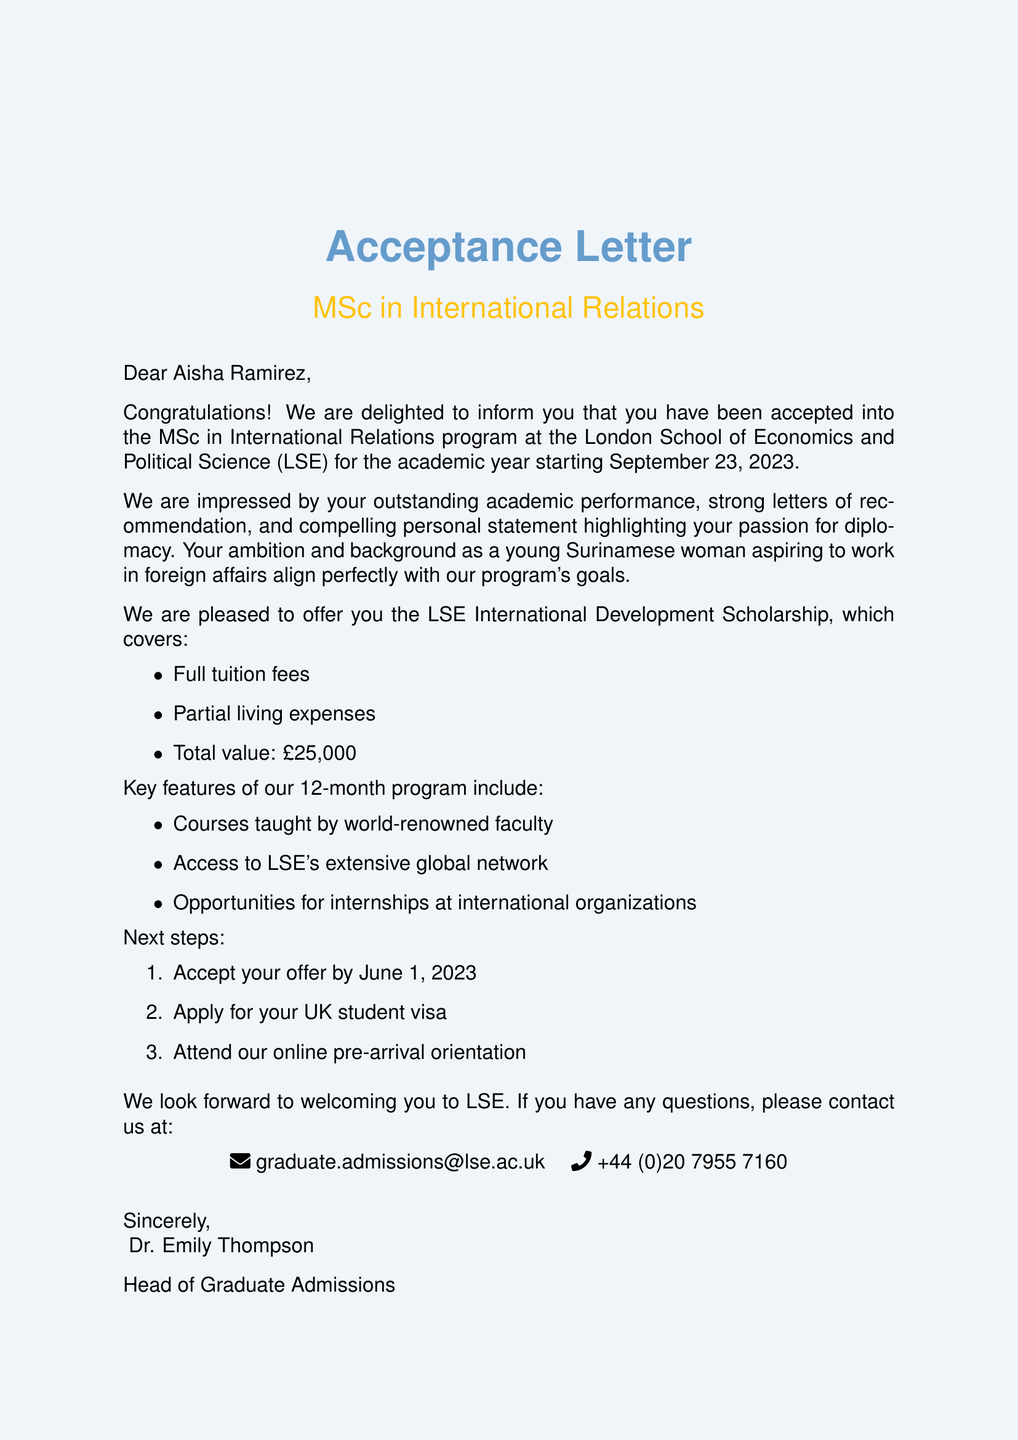What is the name of the university? The university mentioned in the document is the London School of Economics and Political Science.
Answer: London School of Economics and Political Science What is the scholarship amount? The scholarship amount offered is clearly stated in the document.
Answer: £25,000 What is the program duration? The duration of the MSc in International Relations program is specified in the document.
Answer: 12 months Who is the head of graduate admissions? The document provides the name and title of the admissions officer.
Answer: Dr. Emily Thompson By what date should the offer be accepted? The document outlines the deadline for accepting the offer.
Answer: June 1, 2023 What are the key features of the program? The document lists features that exemplify the program’s offerings.
Answer: Courses taught by world-renowned faculty, access to LSE's extensive global network, and opportunities for internships at international organizations What is the next step after accepting the offer? This is a sequence related to actions after accepting the admission offer mentioned in the document.
Answer: Apply for UK student visa What is the starting date of the program? The program starting date is explicitly mentioned in the document.
Answer: September 23, 2023 What should be emphasized in the personal statement? The document indicates qualities to be highlighted in the personal statement.
Answer: Passion for diplomacy 